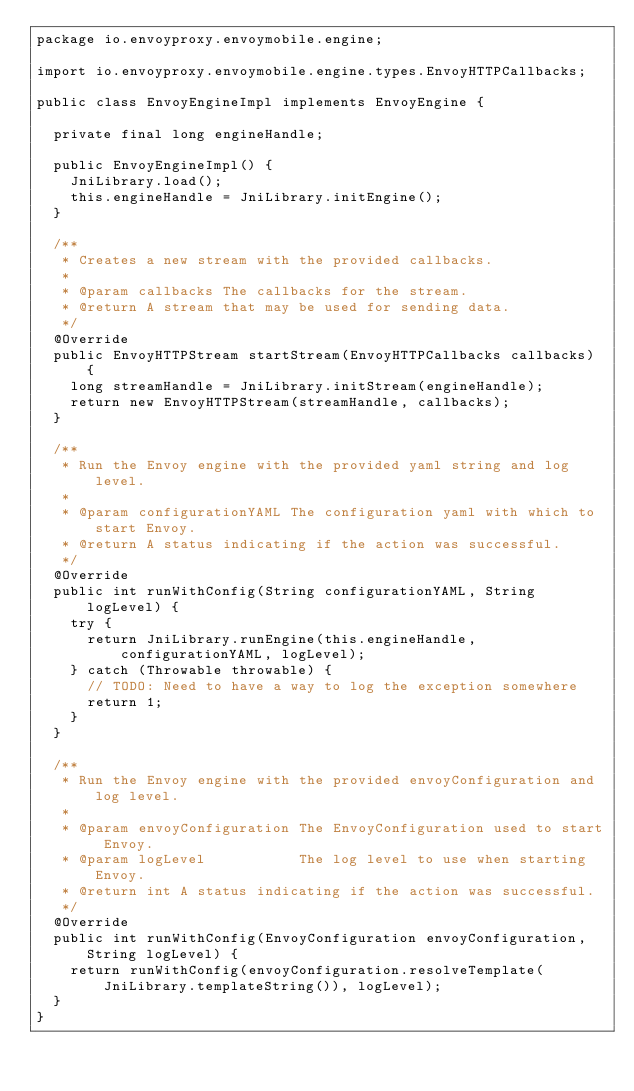Convert code to text. <code><loc_0><loc_0><loc_500><loc_500><_Java_>package io.envoyproxy.envoymobile.engine;

import io.envoyproxy.envoymobile.engine.types.EnvoyHTTPCallbacks;

public class EnvoyEngineImpl implements EnvoyEngine {

  private final long engineHandle;

  public EnvoyEngineImpl() {
    JniLibrary.load();
    this.engineHandle = JniLibrary.initEngine();
  }

  /**
   * Creates a new stream with the provided callbacks.
   *
   * @param callbacks The callbacks for the stream.
   * @return A stream that may be used for sending data.
   */
  @Override
  public EnvoyHTTPStream startStream(EnvoyHTTPCallbacks callbacks) {
    long streamHandle = JniLibrary.initStream(engineHandle);
    return new EnvoyHTTPStream(streamHandle, callbacks);
  }

  /**
   * Run the Envoy engine with the provided yaml string and log level.
   *
   * @param configurationYAML The configuration yaml with which to start Envoy.
   * @return A status indicating if the action was successful.
   */
  @Override
  public int runWithConfig(String configurationYAML, String logLevel) {
    try {
      return JniLibrary.runEngine(this.engineHandle, configurationYAML, logLevel);
    } catch (Throwable throwable) {
      // TODO: Need to have a way to log the exception somewhere
      return 1;
    }
  }

  /**
   * Run the Envoy engine with the provided envoyConfiguration and log level.
   *
   * @param envoyConfiguration The EnvoyConfiguration used to start Envoy.
   * @param logLevel           The log level to use when starting Envoy.
   * @return int A status indicating if the action was successful.
   */
  @Override
  public int runWithConfig(EnvoyConfiguration envoyConfiguration, String logLevel) {
    return runWithConfig(envoyConfiguration.resolveTemplate(JniLibrary.templateString()), logLevel);
  }
}
</code> 